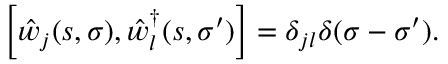<formula> <loc_0><loc_0><loc_500><loc_500>\left [ \hat { w } _ { j } ( s , \sigma ) , \hat { w } _ { l } ^ { \dag } ( s , \sigma ^ { \prime } ) \right ] = \delta _ { j l } \delta ( \sigma - \sigma ^ { \prime } ) .</formula> 